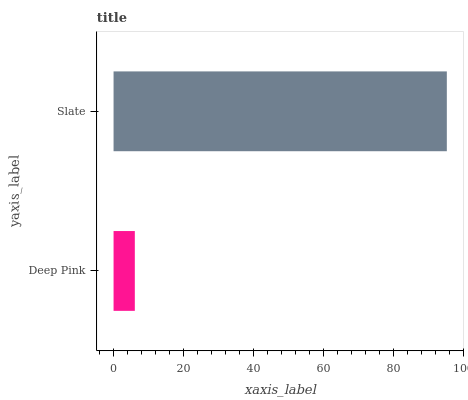Is Deep Pink the minimum?
Answer yes or no. Yes. Is Slate the maximum?
Answer yes or no. Yes. Is Slate the minimum?
Answer yes or no. No. Is Slate greater than Deep Pink?
Answer yes or no. Yes. Is Deep Pink less than Slate?
Answer yes or no. Yes. Is Deep Pink greater than Slate?
Answer yes or no. No. Is Slate less than Deep Pink?
Answer yes or no. No. Is Slate the high median?
Answer yes or no. Yes. Is Deep Pink the low median?
Answer yes or no. Yes. Is Deep Pink the high median?
Answer yes or no. No. Is Slate the low median?
Answer yes or no. No. 